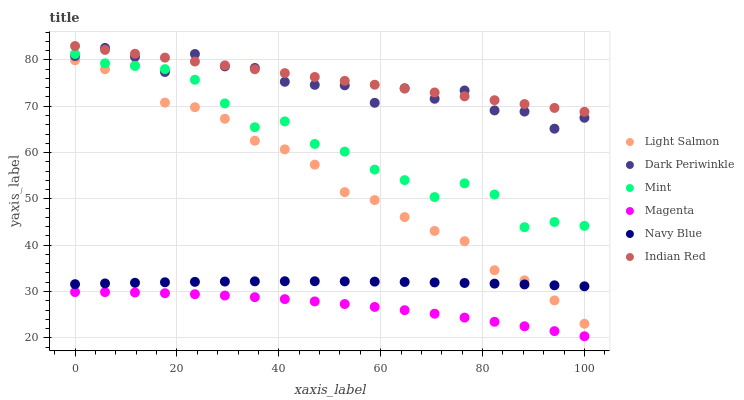Does Magenta have the minimum area under the curve?
Answer yes or no. Yes. Does Indian Red have the maximum area under the curve?
Answer yes or no. Yes. Does Navy Blue have the minimum area under the curve?
Answer yes or no. No. Does Navy Blue have the maximum area under the curve?
Answer yes or no. No. Is Indian Red the smoothest?
Answer yes or no. Yes. Is Dark Periwinkle the roughest?
Answer yes or no. Yes. Is Navy Blue the smoothest?
Answer yes or no. No. Is Navy Blue the roughest?
Answer yes or no. No. Does Magenta have the lowest value?
Answer yes or no. Yes. Does Navy Blue have the lowest value?
Answer yes or no. No. Does Indian Red have the highest value?
Answer yes or no. Yes. Does Navy Blue have the highest value?
Answer yes or no. No. Is Magenta less than Navy Blue?
Answer yes or no. Yes. Is Indian Red greater than Light Salmon?
Answer yes or no. Yes. Does Mint intersect Dark Periwinkle?
Answer yes or no. Yes. Is Mint less than Dark Periwinkle?
Answer yes or no. No. Is Mint greater than Dark Periwinkle?
Answer yes or no. No. Does Magenta intersect Navy Blue?
Answer yes or no. No. 